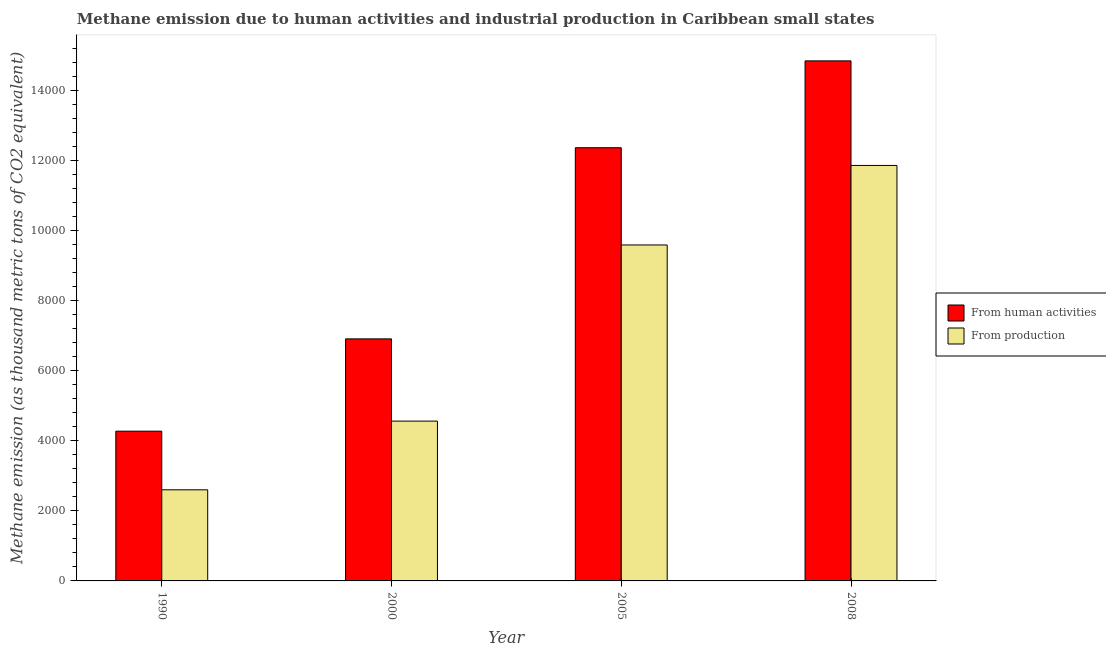How many different coloured bars are there?
Ensure brevity in your answer.  2. Are the number of bars per tick equal to the number of legend labels?
Make the answer very short. Yes. What is the amount of emissions generated from industries in 1990?
Your answer should be very brief. 2599.9. Across all years, what is the maximum amount of emissions generated from industries?
Offer a very short reply. 1.19e+04. Across all years, what is the minimum amount of emissions generated from industries?
Give a very brief answer. 2599.9. In which year was the amount of emissions generated from industries maximum?
Provide a succinct answer. 2008. In which year was the amount of emissions generated from industries minimum?
Ensure brevity in your answer.  1990. What is the total amount of emissions generated from industries in the graph?
Provide a succinct answer. 2.86e+04. What is the difference between the amount of emissions generated from industries in 1990 and that in 2008?
Ensure brevity in your answer.  -9255.6. What is the difference between the amount of emissions generated from industries in 2000 and the amount of emissions from human activities in 2005?
Your response must be concise. -5026. What is the average amount of emissions generated from industries per year?
Offer a very short reply. 7150.65. In the year 2000, what is the difference between the amount of emissions from human activities and amount of emissions generated from industries?
Offer a very short reply. 0. In how many years, is the amount of emissions from human activities greater than 7200 thousand metric tons?
Make the answer very short. 2. What is the ratio of the amount of emissions generated from industries in 1990 to that in 2005?
Make the answer very short. 0.27. Is the amount of emissions generated from industries in 1990 less than that in 2008?
Provide a succinct answer. Yes. Is the difference between the amount of emissions from human activities in 2005 and 2008 greater than the difference between the amount of emissions generated from industries in 2005 and 2008?
Offer a very short reply. No. What is the difference between the highest and the second highest amount of emissions generated from industries?
Your response must be concise. 2268.9. What is the difference between the highest and the lowest amount of emissions generated from industries?
Make the answer very short. 9255.6. Is the sum of the amount of emissions from human activities in 1990 and 2000 greater than the maximum amount of emissions generated from industries across all years?
Keep it short and to the point. No. What does the 1st bar from the left in 2005 represents?
Offer a very short reply. From human activities. What does the 1st bar from the right in 2008 represents?
Offer a very short reply. From production. How many bars are there?
Your response must be concise. 8. Are all the bars in the graph horizontal?
Provide a short and direct response. No. Are the values on the major ticks of Y-axis written in scientific E-notation?
Give a very brief answer. No. What is the title of the graph?
Ensure brevity in your answer.  Methane emission due to human activities and industrial production in Caribbean small states. Does "Exports of goods" appear as one of the legend labels in the graph?
Give a very brief answer. No. What is the label or title of the X-axis?
Your response must be concise. Year. What is the label or title of the Y-axis?
Make the answer very short. Methane emission (as thousand metric tons of CO2 equivalent). What is the Methane emission (as thousand metric tons of CO2 equivalent) in From human activities in 1990?
Your answer should be compact. 4272.7. What is the Methane emission (as thousand metric tons of CO2 equivalent) of From production in 1990?
Your response must be concise. 2599.9. What is the Methane emission (as thousand metric tons of CO2 equivalent) of From human activities in 2000?
Ensure brevity in your answer.  6906.7. What is the Methane emission (as thousand metric tons of CO2 equivalent) in From production in 2000?
Make the answer very short. 4560.6. What is the Methane emission (as thousand metric tons of CO2 equivalent) of From human activities in 2005?
Your response must be concise. 1.24e+04. What is the Methane emission (as thousand metric tons of CO2 equivalent) of From production in 2005?
Provide a short and direct response. 9586.6. What is the Methane emission (as thousand metric tons of CO2 equivalent) of From human activities in 2008?
Provide a succinct answer. 1.48e+04. What is the Methane emission (as thousand metric tons of CO2 equivalent) of From production in 2008?
Offer a very short reply. 1.19e+04. Across all years, what is the maximum Methane emission (as thousand metric tons of CO2 equivalent) in From human activities?
Give a very brief answer. 1.48e+04. Across all years, what is the maximum Methane emission (as thousand metric tons of CO2 equivalent) in From production?
Ensure brevity in your answer.  1.19e+04. Across all years, what is the minimum Methane emission (as thousand metric tons of CO2 equivalent) in From human activities?
Make the answer very short. 4272.7. Across all years, what is the minimum Methane emission (as thousand metric tons of CO2 equivalent) in From production?
Give a very brief answer. 2599.9. What is the total Methane emission (as thousand metric tons of CO2 equivalent) in From human activities in the graph?
Your response must be concise. 3.84e+04. What is the total Methane emission (as thousand metric tons of CO2 equivalent) in From production in the graph?
Make the answer very short. 2.86e+04. What is the difference between the Methane emission (as thousand metric tons of CO2 equivalent) in From human activities in 1990 and that in 2000?
Your answer should be compact. -2634. What is the difference between the Methane emission (as thousand metric tons of CO2 equivalent) in From production in 1990 and that in 2000?
Keep it short and to the point. -1960.7. What is the difference between the Methane emission (as thousand metric tons of CO2 equivalent) in From human activities in 1990 and that in 2005?
Your response must be concise. -8088.5. What is the difference between the Methane emission (as thousand metric tons of CO2 equivalent) of From production in 1990 and that in 2005?
Provide a short and direct response. -6986.7. What is the difference between the Methane emission (as thousand metric tons of CO2 equivalent) in From human activities in 1990 and that in 2008?
Ensure brevity in your answer.  -1.06e+04. What is the difference between the Methane emission (as thousand metric tons of CO2 equivalent) of From production in 1990 and that in 2008?
Provide a succinct answer. -9255.6. What is the difference between the Methane emission (as thousand metric tons of CO2 equivalent) of From human activities in 2000 and that in 2005?
Ensure brevity in your answer.  -5454.5. What is the difference between the Methane emission (as thousand metric tons of CO2 equivalent) in From production in 2000 and that in 2005?
Provide a succinct answer. -5026. What is the difference between the Methane emission (as thousand metric tons of CO2 equivalent) in From human activities in 2000 and that in 2008?
Your response must be concise. -7932.8. What is the difference between the Methane emission (as thousand metric tons of CO2 equivalent) in From production in 2000 and that in 2008?
Give a very brief answer. -7294.9. What is the difference between the Methane emission (as thousand metric tons of CO2 equivalent) in From human activities in 2005 and that in 2008?
Your response must be concise. -2478.3. What is the difference between the Methane emission (as thousand metric tons of CO2 equivalent) of From production in 2005 and that in 2008?
Keep it short and to the point. -2268.9. What is the difference between the Methane emission (as thousand metric tons of CO2 equivalent) of From human activities in 1990 and the Methane emission (as thousand metric tons of CO2 equivalent) of From production in 2000?
Give a very brief answer. -287.9. What is the difference between the Methane emission (as thousand metric tons of CO2 equivalent) of From human activities in 1990 and the Methane emission (as thousand metric tons of CO2 equivalent) of From production in 2005?
Make the answer very short. -5313.9. What is the difference between the Methane emission (as thousand metric tons of CO2 equivalent) in From human activities in 1990 and the Methane emission (as thousand metric tons of CO2 equivalent) in From production in 2008?
Your response must be concise. -7582.8. What is the difference between the Methane emission (as thousand metric tons of CO2 equivalent) in From human activities in 2000 and the Methane emission (as thousand metric tons of CO2 equivalent) in From production in 2005?
Provide a short and direct response. -2679.9. What is the difference between the Methane emission (as thousand metric tons of CO2 equivalent) in From human activities in 2000 and the Methane emission (as thousand metric tons of CO2 equivalent) in From production in 2008?
Give a very brief answer. -4948.8. What is the difference between the Methane emission (as thousand metric tons of CO2 equivalent) of From human activities in 2005 and the Methane emission (as thousand metric tons of CO2 equivalent) of From production in 2008?
Keep it short and to the point. 505.7. What is the average Methane emission (as thousand metric tons of CO2 equivalent) in From human activities per year?
Ensure brevity in your answer.  9595.02. What is the average Methane emission (as thousand metric tons of CO2 equivalent) in From production per year?
Provide a short and direct response. 7150.65. In the year 1990, what is the difference between the Methane emission (as thousand metric tons of CO2 equivalent) in From human activities and Methane emission (as thousand metric tons of CO2 equivalent) in From production?
Your answer should be very brief. 1672.8. In the year 2000, what is the difference between the Methane emission (as thousand metric tons of CO2 equivalent) of From human activities and Methane emission (as thousand metric tons of CO2 equivalent) of From production?
Provide a succinct answer. 2346.1. In the year 2005, what is the difference between the Methane emission (as thousand metric tons of CO2 equivalent) in From human activities and Methane emission (as thousand metric tons of CO2 equivalent) in From production?
Offer a very short reply. 2774.6. In the year 2008, what is the difference between the Methane emission (as thousand metric tons of CO2 equivalent) of From human activities and Methane emission (as thousand metric tons of CO2 equivalent) of From production?
Offer a very short reply. 2984. What is the ratio of the Methane emission (as thousand metric tons of CO2 equivalent) in From human activities in 1990 to that in 2000?
Make the answer very short. 0.62. What is the ratio of the Methane emission (as thousand metric tons of CO2 equivalent) of From production in 1990 to that in 2000?
Ensure brevity in your answer.  0.57. What is the ratio of the Methane emission (as thousand metric tons of CO2 equivalent) in From human activities in 1990 to that in 2005?
Your answer should be very brief. 0.35. What is the ratio of the Methane emission (as thousand metric tons of CO2 equivalent) in From production in 1990 to that in 2005?
Offer a very short reply. 0.27. What is the ratio of the Methane emission (as thousand metric tons of CO2 equivalent) in From human activities in 1990 to that in 2008?
Provide a short and direct response. 0.29. What is the ratio of the Methane emission (as thousand metric tons of CO2 equivalent) of From production in 1990 to that in 2008?
Offer a terse response. 0.22. What is the ratio of the Methane emission (as thousand metric tons of CO2 equivalent) of From human activities in 2000 to that in 2005?
Your response must be concise. 0.56. What is the ratio of the Methane emission (as thousand metric tons of CO2 equivalent) in From production in 2000 to that in 2005?
Your answer should be compact. 0.48. What is the ratio of the Methane emission (as thousand metric tons of CO2 equivalent) of From human activities in 2000 to that in 2008?
Your response must be concise. 0.47. What is the ratio of the Methane emission (as thousand metric tons of CO2 equivalent) in From production in 2000 to that in 2008?
Offer a very short reply. 0.38. What is the ratio of the Methane emission (as thousand metric tons of CO2 equivalent) in From human activities in 2005 to that in 2008?
Give a very brief answer. 0.83. What is the ratio of the Methane emission (as thousand metric tons of CO2 equivalent) in From production in 2005 to that in 2008?
Ensure brevity in your answer.  0.81. What is the difference between the highest and the second highest Methane emission (as thousand metric tons of CO2 equivalent) of From human activities?
Keep it short and to the point. 2478.3. What is the difference between the highest and the second highest Methane emission (as thousand metric tons of CO2 equivalent) of From production?
Your answer should be very brief. 2268.9. What is the difference between the highest and the lowest Methane emission (as thousand metric tons of CO2 equivalent) in From human activities?
Your answer should be compact. 1.06e+04. What is the difference between the highest and the lowest Methane emission (as thousand metric tons of CO2 equivalent) in From production?
Make the answer very short. 9255.6. 